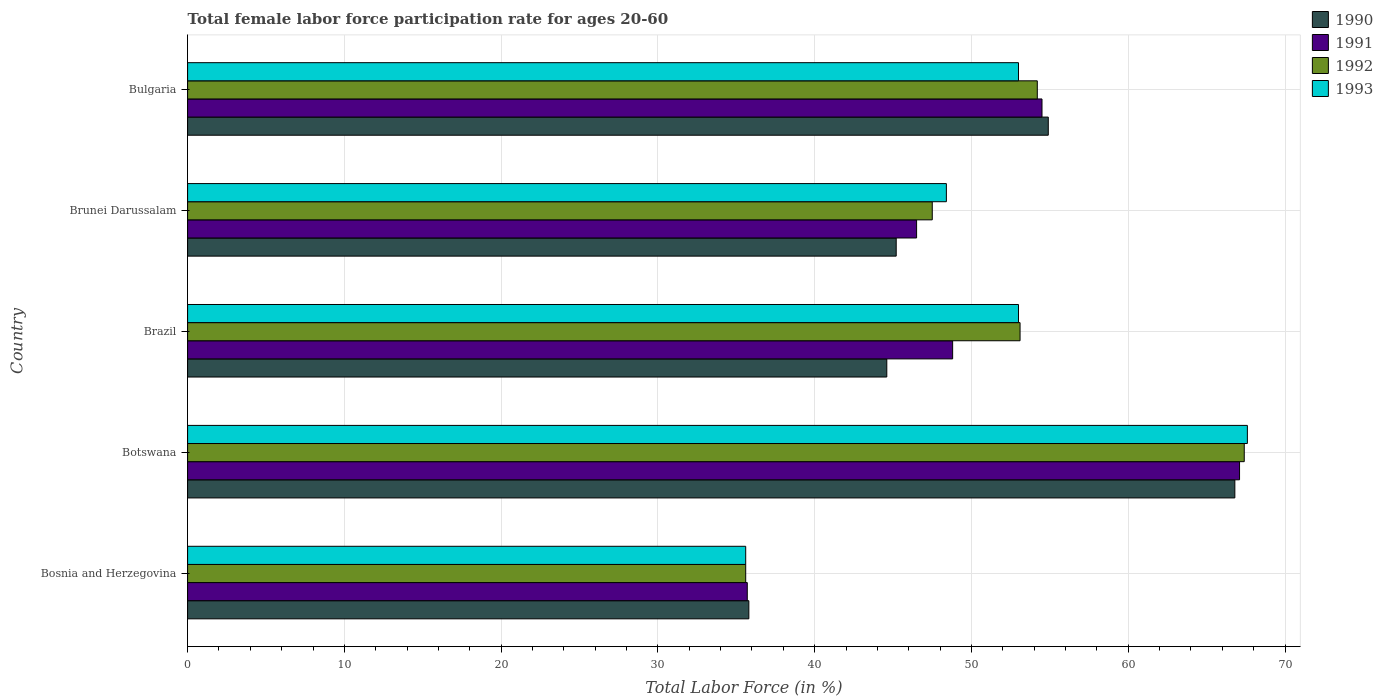How many different coloured bars are there?
Offer a very short reply. 4. Are the number of bars per tick equal to the number of legend labels?
Offer a very short reply. Yes. Are the number of bars on each tick of the Y-axis equal?
Your response must be concise. Yes. How many bars are there on the 1st tick from the top?
Provide a short and direct response. 4. In how many cases, is the number of bars for a given country not equal to the number of legend labels?
Give a very brief answer. 0. What is the female labor force participation rate in 1992 in Bosnia and Herzegovina?
Keep it short and to the point. 35.6. Across all countries, what is the maximum female labor force participation rate in 1993?
Provide a short and direct response. 67.6. Across all countries, what is the minimum female labor force participation rate in 1991?
Your answer should be very brief. 35.7. In which country was the female labor force participation rate in 1990 maximum?
Ensure brevity in your answer.  Botswana. In which country was the female labor force participation rate in 1992 minimum?
Ensure brevity in your answer.  Bosnia and Herzegovina. What is the total female labor force participation rate in 1991 in the graph?
Provide a succinct answer. 252.6. What is the difference between the female labor force participation rate in 1992 in Brunei Darussalam and that in Bulgaria?
Ensure brevity in your answer.  -6.7. What is the difference between the female labor force participation rate in 1992 in Botswana and the female labor force participation rate in 1990 in Bulgaria?
Offer a terse response. 12.5. What is the average female labor force participation rate in 1990 per country?
Your answer should be compact. 49.46. What is the difference between the female labor force participation rate in 1991 and female labor force participation rate in 1990 in Brunei Darussalam?
Provide a short and direct response. 1.3. In how many countries, is the female labor force participation rate in 1992 greater than 62 %?
Provide a short and direct response. 1. What is the ratio of the female labor force participation rate in 1993 in Botswana to that in Brazil?
Your answer should be compact. 1.28. What is the difference between the highest and the second highest female labor force participation rate in 1992?
Give a very brief answer. 13.2. What is the difference between the highest and the lowest female labor force participation rate in 1991?
Offer a terse response. 31.4. Is it the case that in every country, the sum of the female labor force participation rate in 1990 and female labor force participation rate in 1991 is greater than the sum of female labor force participation rate in 1992 and female labor force participation rate in 1993?
Give a very brief answer. No. What does the 4th bar from the bottom in Botswana represents?
Your response must be concise. 1993. Are all the bars in the graph horizontal?
Make the answer very short. Yes. How many countries are there in the graph?
Provide a short and direct response. 5. Are the values on the major ticks of X-axis written in scientific E-notation?
Make the answer very short. No. Does the graph contain any zero values?
Offer a very short reply. No. Where does the legend appear in the graph?
Your response must be concise. Top right. How many legend labels are there?
Offer a very short reply. 4. What is the title of the graph?
Provide a succinct answer. Total female labor force participation rate for ages 20-60. Does "1965" appear as one of the legend labels in the graph?
Your response must be concise. No. What is the Total Labor Force (in %) in 1990 in Bosnia and Herzegovina?
Your answer should be compact. 35.8. What is the Total Labor Force (in %) in 1991 in Bosnia and Herzegovina?
Give a very brief answer. 35.7. What is the Total Labor Force (in %) of 1992 in Bosnia and Herzegovina?
Your answer should be compact. 35.6. What is the Total Labor Force (in %) of 1993 in Bosnia and Herzegovina?
Your response must be concise. 35.6. What is the Total Labor Force (in %) in 1990 in Botswana?
Provide a short and direct response. 66.8. What is the Total Labor Force (in %) in 1991 in Botswana?
Your response must be concise. 67.1. What is the Total Labor Force (in %) of 1992 in Botswana?
Provide a succinct answer. 67.4. What is the Total Labor Force (in %) in 1993 in Botswana?
Your response must be concise. 67.6. What is the Total Labor Force (in %) in 1990 in Brazil?
Provide a short and direct response. 44.6. What is the Total Labor Force (in %) in 1991 in Brazil?
Make the answer very short. 48.8. What is the Total Labor Force (in %) of 1992 in Brazil?
Your response must be concise. 53.1. What is the Total Labor Force (in %) of 1990 in Brunei Darussalam?
Offer a very short reply. 45.2. What is the Total Labor Force (in %) in 1991 in Brunei Darussalam?
Offer a very short reply. 46.5. What is the Total Labor Force (in %) of 1992 in Brunei Darussalam?
Give a very brief answer. 47.5. What is the Total Labor Force (in %) of 1993 in Brunei Darussalam?
Ensure brevity in your answer.  48.4. What is the Total Labor Force (in %) in 1990 in Bulgaria?
Make the answer very short. 54.9. What is the Total Labor Force (in %) of 1991 in Bulgaria?
Your answer should be very brief. 54.5. What is the Total Labor Force (in %) of 1992 in Bulgaria?
Your answer should be very brief. 54.2. Across all countries, what is the maximum Total Labor Force (in %) of 1990?
Your answer should be compact. 66.8. Across all countries, what is the maximum Total Labor Force (in %) of 1991?
Ensure brevity in your answer.  67.1. Across all countries, what is the maximum Total Labor Force (in %) of 1992?
Your answer should be compact. 67.4. Across all countries, what is the maximum Total Labor Force (in %) in 1993?
Your answer should be very brief. 67.6. Across all countries, what is the minimum Total Labor Force (in %) of 1990?
Your response must be concise. 35.8. Across all countries, what is the minimum Total Labor Force (in %) in 1991?
Offer a very short reply. 35.7. Across all countries, what is the minimum Total Labor Force (in %) in 1992?
Your answer should be compact. 35.6. Across all countries, what is the minimum Total Labor Force (in %) of 1993?
Your answer should be compact. 35.6. What is the total Total Labor Force (in %) of 1990 in the graph?
Give a very brief answer. 247.3. What is the total Total Labor Force (in %) of 1991 in the graph?
Offer a terse response. 252.6. What is the total Total Labor Force (in %) in 1992 in the graph?
Your answer should be compact. 257.8. What is the total Total Labor Force (in %) of 1993 in the graph?
Make the answer very short. 257.6. What is the difference between the Total Labor Force (in %) in 1990 in Bosnia and Herzegovina and that in Botswana?
Offer a terse response. -31. What is the difference between the Total Labor Force (in %) of 1991 in Bosnia and Herzegovina and that in Botswana?
Offer a terse response. -31.4. What is the difference between the Total Labor Force (in %) of 1992 in Bosnia and Herzegovina and that in Botswana?
Your response must be concise. -31.8. What is the difference between the Total Labor Force (in %) in 1993 in Bosnia and Herzegovina and that in Botswana?
Keep it short and to the point. -32. What is the difference between the Total Labor Force (in %) of 1992 in Bosnia and Herzegovina and that in Brazil?
Your answer should be compact. -17.5. What is the difference between the Total Labor Force (in %) of 1993 in Bosnia and Herzegovina and that in Brazil?
Your answer should be very brief. -17.4. What is the difference between the Total Labor Force (in %) in 1992 in Bosnia and Herzegovina and that in Brunei Darussalam?
Ensure brevity in your answer.  -11.9. What is the difference between the Total Labor Force (in %) of 1990 in Bosnia and Herzegovina and that in Bulgaria?
Offer a terse response. -19.1. What is the difference between the Total Labor Force (in %) in 1991 in Bosnia and Herzegovina and that in Bulgaria?
Keep it short and to the point. -18.8. What is the difference between the Total Labor Force (in %) in 1992 in Bosnia and Herzegovina and that in Bulgaria?
Offer a very short reply. -18.6. What is the difference between the Total Labor Force (in %) of 1993 in Bosnia and Herzegovina and that in Bulgaria?
Your answer should be compact. -17.4. What is the difference between the Total Labor Force (in %) in 1990 in Botswana and that in Brazil?
Give a very brief answer. 22.2. What is the difference between the Total Labor Force (in %) of 1991 in Botswana and that in Brazil?
Offer a very short reply. 18.3. What is the difference between the Total Labor Force (in %) of 1993 in Botswana and that in Brazil?
Make the answer very short. 14.6. What is the difference between the Total Labor Force (in %) in 1990 in Botswana and that in Brunei Darussalam?
Offer a very short reply. 21.6. What is the difference between the Total Labor Force (in %) in 1991 in Botswana and that in Brunei Darussalam?
Provide a short and direct response. 20.6. What is the difference between the Total Labor Force (in %) in 1992 in Botswana and that in Brunei Darussalam?
Your answer should be very brief. 19.9. What is the difference between the Total Labor Force (in %) of 1991 in Botswana and that in Bulgaria?
Give a very brief answer. 12.6. What is the difference between the Total Labor Force (in %) in 1993 in Botswana and that in Bulgaria?
Ensure brevity in your answer.  14.6. What is the difference between the Total Labor Force (in %) in 1990 in Brazil and that in Brunei Darussalam?
Ensure brevity in your answer.  -0.6. What is the difference between the Total Labor Force (in %) in 1991 in Brazil and that in Brunei Darussalam?
Offer a terse response. 2.3. What is the difference between the Total Labor Force (in %) in 1992 in Brazil and that in Brunei Darussalam?
Your answer should be compact. 5.6. What is the difference between the Total Labor Force (in %) of 1992 in Brazil and that in Bulgaria?
Make the answer very short. -1.1. What is the difference between the Total Labor Force (in %) in 1990 in Bosnia and Herzegovina and the Total Labor Force (in %) in 1991 in Botswana?
Make the answer very short. -31.3. What is the difference between the Total Labor Force (in %) in 1990 in Bosnia and Herzegovina and the Total Labor Force (in %) in 1992 in Botswana?
Make the answer very short. -31.6. What is the difference between the Total Labor Force (in %) in 1990 in Bosnia and Herzegovina and the Total Labor Force (in %) in 1993 in Botswana?
Offer a terse response. -31.8. What is the difference between the Total Labor Force (in %) in 1991 in Bosnia and Herzegovina and the Total Labor Force (in %) in 1992 in Botswana?
Provide a short and direct response. -31.7. What is the difference between the Total Labor Force (in %) in 1991 in Bosnia and Herzegovina and the Total Labor Force (in %) in 1993 in Botswana?
Provide a succinct answer. -31.9. What is the difference between the Total Labor Force (in %) of 1992 in Bosnia and Herzegovina and the Total Labor Force (in %) of 1993 in Botswana?
Give a very brief answer. -32. What is the difference between the Total Labor Force (in %) in 1990 in Bosnia and Herzegovina and the Total Labor Force (in %) in 1991 in Brazil?
Your response must be concise. -13. What is the difference between the Total Labor Force (in %) of 1990 in Bosnia and Herzegovina and the Total Labor Force (in %) of 1992 in Brazil?
Give a very brief answer. -17.3. What is the difference between the Total Labor Force (in %) of 1990 in Bosnia and Herzegovina and the Total Labor Force (in %) of 1993 in Brazil?
Your answer should be compact. -17.2. What is the difference between the Total Labor Force (in %) in 1991 in Bosnia and Herzegovina and the Total Labor Force (in %) in 1992 in Brazil?
Offer a very short reply. -17.4. What is the difference between the Total Labor Force (in %) in 1991 in Bosnia and Herzegovina and the Total Labor Force (in %) in 1993 in Brazil?
Provide a short and direct response. -17.3. What is the difference between the Total Labor Force (in %) of 1992 in Bosnia and Herzegovina and the Total Labor Force (in %) of 1993 in Brazil?
Offer a terse response. -17.4. What is the difference between the Total Labor Force (in %) in 1990 in Bosnia and Herzegovina and the Total Labor Force (in %) in 1992 in Brunei Darussalam?
Provide a succinct answer. -11.7. What is the difference between the Total Labor Force (in %) of 1990 in Bosnia and Herzegovina and the Total Labor Force (in %) of 1993 in Brunei Darussalam?
Offer a terse response. -12.6. What is the difference between the Total Labor Force (in %) of 1991 in Bosnia and Herzegovina and the Total Labor Force (in %) of 1992 in Brunei Darussalam?
Give a very brief answer. -11.8. What is the difference between the Total Labor Force (in %) in 1991 in Bosnia and Herzegovina and the Total Labor Force (in %) in 1993 in Brunei Darussalam?
Your answer should be compact. -12.7. What is the difference between the Total Labor Force (in %) of 1990 in Bosnia and Herzegovina and the Total Labor Force (in %) of 1991 in Bulgaria?
Make the answer very short. -18.7. What is the difference between the Total Labor Force (in %) of 1990 in Bosnia and Herzegovina and the Total Labor Force (in %) of 1992 in Bulgaria?
Offer a terse response. -18.4. What is the difference between the Total Labor Force (in %) of 1990 in Bosnia and Herzegovina and the Total Labor Force (in %) of 1993 in Bulgaria?
Provide a succinct answer. -17.2. What is the difference between the Total Labor Force (in %) of 1991 in Bosnia and Herzegovina and the Total Labor Force (in %) of 1992 in Bulgaria?
Ensure brevity in your answer.  -18.5. What is the difference between the Total Labor Force (in %) of 1991 in Bosnia and Herzegovina and the Total Labor Force (in %) of 1993 in Bulgaria?
Give a very brief answer. -17.3. What is the difference between the Total Labor Force (in %) in 1992 in Bosnia and Herzegovina and the Total Labor Force (in %) in 1993 in Bulgaria?
Ensure brevity in your answer.  -17.4. What is the difference between the Total Labor Force (in %) of 1991 in Botswana and the Total Labor Force (in %) of 1993 in Brazil?
Ensure brevity in your answer.  14.1. What is the difference between the Total Labor Force (in %) in 1990 in Botswana and the Total Labor Force (in %) in 1991 in Brunei Darussalam?
Ensure brevity in your answer.  20.3. What is the difference between the Total Labor Force (in %) in 1990 in Botswana and the Total Labor Force (in %) in 1992 in Brunei Darussalam?
Ensure brevity in your answer.  19.3. What is the difference between the Total Labor Force (in %) in 1991 in Botswana and the Total Labor Force (in %) in 1992 in Brunei Darussalam?
Provide a short and direct response. 19.6. What is the difference between the Total Labor Force (in %) in 1991 in Botswana and the Total Labor Force (in %) in 1993 in Brunei Darussalam?
Provide a succinct answer. 18.7. What is the difference between the Total Labor Force (in %) in 1990 in Botswana and the Total Labor Force (in %) in 1992 in Bulgaria?
Keep it short and to the point. 12.6. What is the difference between the Total Labor Force (in %) in 1990 in Botswana and the Total Labor Force (in %) in 1993 in Bulgaria?
Make the answer very short. 13.8. What is the difference between the Total Labor Force (in %) of 1991 in Botswana and the Total Labor Force (in %) of 1993 in Bulgaria?
Your answer should be compact. 14.1. What is the difference between the Total Labor Force (in %) in 1990 in Brazil and the Total Labor Force (in %) in 1991 in Brunei Darussalam?
Ensure brevity in your answer.  -1.9. What is the difference between the Total Labor Force (in %) of 1991 in Brazil and the Total Labor Force (in %) of 1993 in Brunei Darussalam?
Your answer should be compact. 0.4. What is the difference between the Total Labor Force (in %) in 1992 in Brazil and the Total Labor Force (in %) in 1993 in Brunei Darussalam?
Offer a terse response. 4.7. What is the difference between the Total Labor Force (in %) of 1990 in Brazil and the Total Labor Force (in %) of 1991 in Bulgaria?
Give a very brief answer. -9.9. What is the difference between the Total Labor Force (in %) of 1990 in Brazil and the Total Labor Force (in %) of 1992 in Bulgaria?
Your answer should be compact. -9.6. What is the difference between the Total Labor Force (in %) of 1990 in Brazil and the Total Labor Force (in %) of 1993 in Bulgaria?
Provide a short and direct response. -8.4. What is the difference between the Total Labor Force (in %) of 1991 in Brazil and the Total Labor Force (in %) of 1993 in Bulgaria?
Offer a terse response. -4.2. What is the difference between the Total Labor Force (in %) in 1992 in Brazil and the Total Labor Force (in %) in 1993 in Bulgaria?
Your answer should be very brief. 0.1. What is the difference between the Total Labor Force (in %) of 1990 in Brunei Darussalam and the Total Labor Force (in %) of 1992 in Bulgaria?
Offer a terse response. -9. What is the difference between the Total Labor Force (in %) of 1991 in Brunei Darussalam and the Total Labor Force (in %) of 1992 in Bulgaria?
Give a very brief answer. -7.7. What is the average Total Labor Force (in %) of 1990 per country?
Provide a succinct answer. 49.46. What is the average Total Labor Force (in %) in 1991 per country?
Provide a succinct answer. 50.52. What is the average Total Labor Force (in %) in 1992 per country?
Provide a short and direct response. 51.56. What is the average Total Labor Force (in %) of 1993 per country?
Offer a terse response. 51.52. What is the difference between the Total Labor Force (in %) of 1990 and Total Labor Force (in %) of 1993 in Bosnia and Herzegovina?
Offer a terse response. 0.2. What is the difference between the Total Labor Force (in %) in 1991 and Total Labor Force (in %) in 1992 in Bosnia and Herzegovina?
Give a very brief answer. 0.1. What is the difference between the Total Labor Force (in %) in 1991 and Total Labor Force (in %) in 1993 in Bosnia and Herzegovina?
Ensure brevity in your answer.  0.1. What is the difference between the Total Labor Force (in %) of 1990 and Total Labor Force (in %) of 1991 in Botswana?
Offer a very short reply. -0.3. What is the difference between the Total Labor Force (in %) in 1990 and Total Labor Force (in %) in 1992 in Botswana?
Provide a succinct answer. -0.6. What is the difference between the Total Labor Force (in %) in 1991 and Total Labor Force (in %) in 1992 in Botswana?
Offer a very short reply. -0.3. What is the difference between the Total Labor Force (in %) of 1991 and Total Labor Force (in %) of 1993 in Botswana?
Ensure brevity in your answer.  -0.5. What is the difference between the Total Labor Force (in %) in 1992 and Total Labor Force (in %) in 1993 in Botswana?
Provide a succinct answer. -0.2. What is the difference between the Total Labor Force (in %) of 1990 and Total Labor Force (in %) of 1991 in Brazil?
Give a very brief answer. -4.2. What is the difference between the Total Labor Force (in %) in 1990 and Total Labor Force (in %) in 1993 in Brazil?
Your response must be concise. -8.4. What is the difference between the Total Labor Force (in %) of 1991 and Total Labor Force (in %) of 1992 in Brazil?
Your answer should be compact. -4.3. What is the difference between the Total Labor Force (in %) in 1990 and Total Labor Force (in %) in 1991 in Brunei Darussalam?
Your answer should be very brief. -1.3. What is the difference between the Total Labor Force (in %) in 1990 and Total Labor Force (in %) in 1992 in Brunei Darussalam?
Provide a succinct answer. -2.3. What is the difference between the Total Labor Force (in %) of 1991 and Total Labor Force (in %) of 1992 in Brunei Darussalam?
Ensure brevity in your answer.  -1. What is the difference between the Total Labor Force (in %) of 1992 and Total Labor Force (in %) of 1993 in Brunei Darussalam?
Your answer should be compact. -0.9. What is the difference between the Total Labor Force (in %) in 1990 and Total Labor Force (in %) in 1992 in Bulgaria?
Your answer should be very brief. 0.7. What is the difference between the Total Labor Force (in %) of 1990 and Total Labor Force (in %) of 1993 in Bulgaria?
Ensure brevity in your answer.  1.9. What is the difference between the Total Labor Force (in %) of 1992 and Total Labor Force (in %) of 1993 in Bulgaria?
Make the answer very short. 1.2. What is the ratio of the Total Labor Force (in %) in 1990 in Bosnia and Herzegovina to that in Botswana?
Offer a terse response. 0.54. What is the ratio of the Total Labor Force (in %) in 1991 in Bosnia and Herzegovina to that in Botswana?
Give a very brief answer. 0.53. What is the ratio of the Total Labor Force (in %) in 1992 in Bosnia and Herzegovina to that in Botswana?
Offer a terse response. 0.53. What is the ratio of the Total Labor Force (in %) in 1993 in Bosnia and Herzegovina to that in Botswana?
Make the answer very short. 0.53. What is the ratio of the Total Labor Force (in %) in 1990 in Bosnia and Herzegovina to that in Brazil?
Your answer should be very brief. 0.8. What is the ratio of the Total Labor Force (in %) in 1991 in Bosnia and Herzegovina to that in Brazil?
Give a very brief answer. 0.73. What is the ratio of the Total Labor Force (in %) of 1992 in Bosnia and Herzegovina to that in Brazil?
Offer a very short reply. 0.67. What is the ratio of the Total Labor Force (in %) in 1993 in Bosnia and Herzegovina to that in Brazil?
Give a very brief answer. 0.67. What is the ratio of the Total Labor Force (in %) in 1990 in Bosnia and Herzegovina to that in Brunei Darussalam?
Ensure brevity in your answer.  0.79. What is the ratio of the Total Labor Force (in %) in 1991 in Bosnia and Herzegovina to that in Brunei Darussalam?
Ensure brevity in your answer.  0.77. What is the ratio of the Total Labor Force (in %) in 1992 in Bosnia and Herzegovina to that in Brunei Darussalam?
Give a very brief answer. 0.75. What is the ratio of the Total Labor Force (in %) in 1993 in Bosnia and Herzegovina to that in Brunei Darussalam?
Provide a short and direct response. 0.74. What is the ratio of the Total Labor Force (in %) in 1990 in Bosnia and Herzegovina to that in Bulgaria?
Offer a terse response. 0.65. What is the ratio of the Total Labor Force (in %) in 1991 in Bosnia and Herzegovina to that in Bulgaria?
Offer a very short reply. 0.66. What is the ratio of the Total Labor Force (in %) of 1992 in Bosnia and Herzegovina to that in Bulgaria?
Your answer should be compact. 0.66. What is the ratio of the Total Labor Force (in %) in 1993 in Bosnia and Herzegovina to that in Bulgaria?
Your answer should be very brief. 0.67. What is the ratio of the Total Labor Force (in %) of 1990 in Botswana to that in Brazil?
Provide a short and direct response. 1.5. What is the ratio of the Total Labor Force (in %) in 1991 in Botswana to that in Brazil?
Your response must be concise. 1.38. What is the ratio of the Total Labor Force (in %) in 1992 in Botswana to that in Brazil?
Offer a terse response. 1.27. What is the ratio of the Total Labor Force (in %) of 1993 in Botswana to that in Brazil?
Provide a short and direct response. 1.28. What is the ratio of the Total Labor Force (in %) of 1990 in Botswana to that in Brunei Darussalam?
Give a very brief answer. 1.48. What is the ratio of the Total Labor Force (in %) in 1991 in Botswana to that in Brunei Darussalam?
Offer a terse response. 1.44. What is the ratio of the Total Labor Force (in %) in 1992 in Botswana to that in Brunei Darussalam?
Ensure brevity in your answer.  1.42. What is the ratio of the Total Labor Force (in %) in 1993 in Botswana to that in Brunei Darussalam?
Make the answer very short. 1.4. What is the ratio of the Total Labor Force (in %) of 1990 in Botswana to that in Bulgaria?
Your response must be concise. 1.22. What is the ratio of the Total Labor Force (in %) in 1991 in Botswana to that in Bulgaria?
Ensure brevity in your answer.  1.23. What is the ratio of the Total Labor Force (in %) in 1992 in Botswana to that in Bulgaria?
Offer a very short reply. 1.24. What is the ratio of the Total Labor Force (in %) of 1993 in Botswana to that in Bulgaria?
Your answer should be compact. 1.28. What is the ratio of the Total Labor Force (in %) of 1990 in Brazil to that in Brunei Darussalam?
Provide a short and direct response. 0.99. What is the ratio of the Total Labor Force (in %) of 1991 in Brazil to that in Brunei Darussalam?
Give a very brief answer. 1.05. What is the ratio of the Total Labor Force (in %) in 1992 in Brazil to that in Brunei Darussalam?
Make the answer very short. 1.12. What is the ratio of the Total Labor Force (in %) in 1993 in Brazil to that in Brunei Darussalam?
Ensure brevity in your answer.  1.09. What is the ratio of the Total Labor Force (in %) in 1990 in Brazil to that in Bulgaria?
Provide a succinct answer. 0.81. What is the ratio of the Total Labor Force (in %) in 1991 in Brazil to that in Bulgaria?
Ensure brevity in your answer.  0.9. What is the ratio of the Total Labor Force (in %) of 1992 in Brazil to that in Bulgaria?
Make the answer very short. 0.98. What is the ratio of the Total Labor Force (in %) of 1993 in Brazil to that in Bulgaria?
Make the answer very short. 1. What is the ratio of the Total Labor Force (in %) of 1990 in Brunei Darussalam to that in Bulgaria?
Offer a very short reply. 0.82. What is the ratio of the Total Labor Force (in %) of 1991 in Brunei Darussalam to that in Bulgaria?
Your response must be concise. 0.85. What is the ratio of the Total Labor Force (in %) in 1992 in Brunei Darussalam to that in Bulgaria?
Give a very brief answer. 0.88. What is the ratio of the Total Labor Force (in %) in 1993 in Brunei Darussalam to that in Bulgaria?
Provide a succinct answer. 0.91. What is the difference between the highest and the second highest Total Labor Force (in %) of 1990?
Make the answer very short. 11.9. What is the difference between the highest and the lowest Total Labor Force (in %) of 1990?
Your answer should be compact. 31. What is the difference between the highest and the lowest Total Labor Force (in %) of 1991?
Keep it short and to the point. 31.4. What is the difference between the highest and the lowest Total Labor Force (in %) of 1992?
Offer a very short reply. 31.8. 